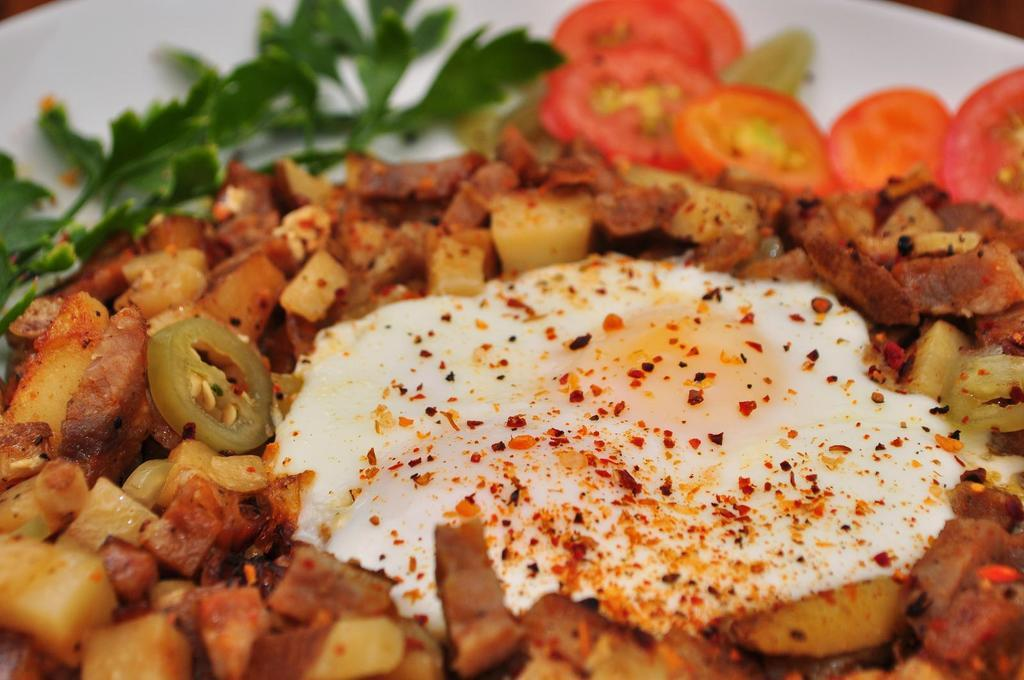What is the main dish in the image? There is an omelet in the image. What accompanies the omelet? There are vegetables pieces around the omelet. How are the vegetables prepared? The vegetables pieces are fried. What type of plant material is present in the image? There are leaves and tomato pieces in the image. What is the color of the plate on which the omelet and vegetables are served? The plate is white in color. Can you see any fog in the image? No, there is no fog present in the image. Is there anyone shaking a hand in the image? There is no hand-shaking activity depicted in the image. 